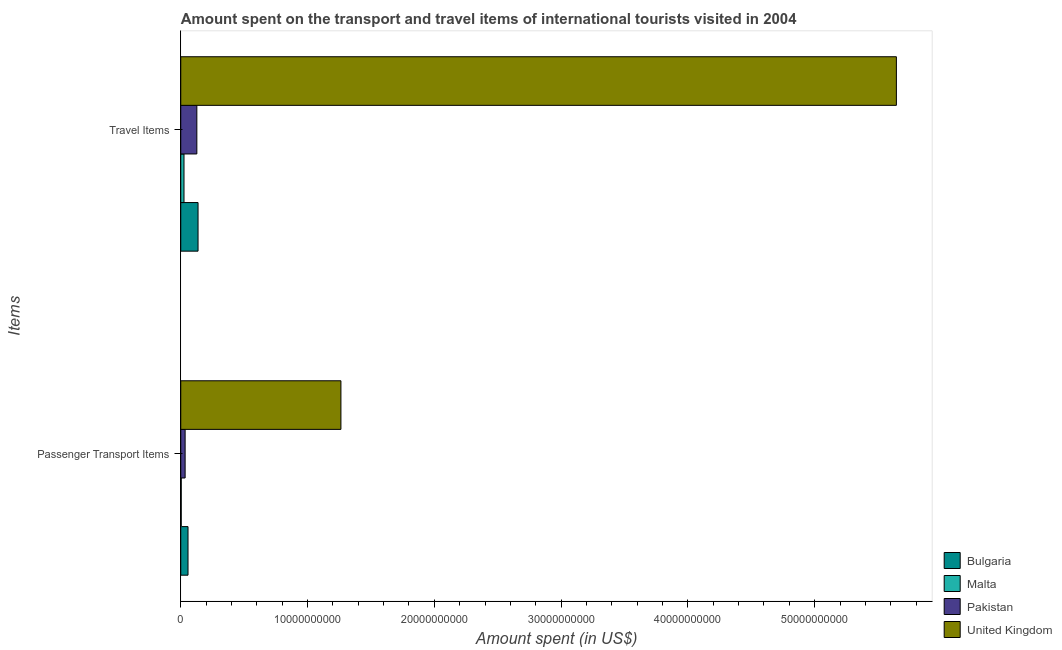Are the number of bars per tick equal to the number of legend labels?
Your answer should be very brief. Yes. Are the number of bars on each tick of the Y-axis equal?
Offer a very short reply. Yes. How many bars are there on the 1st tick from the top?
Ensure brevity in your answer.  4. How many bars are there on the 1st tick from the bottom?
Make the answer very short. 4. What is the label of the 2nd group of bars from the top?
Your answer should be very brief. Passenger Transport Items. What is the amount spent on passenger transport items in Bulgaria?
Keep it short and to the point. 5.72e+08. Across all countries, what is the maximum amount spent on passenger transport items?
Provide a short and direct response. 1.26e+1. Across all countries, what is the minimum amount spent on passenger transport items?
Offer a very short reply. 3.60e+07. In which country was the amount spent in travel items maximum?
Offer a very short reply. United Kingdom. In which country was the amount spent in travel items minimum?
Your answer should be compact. Malta. What is the total amount spent in travel items in the graph?
Offer a terse response. 5.93e+1. What is the difference between the amount spent on passenger transport items in United Kingdom and that in Pakistan?
Offer a terse response. 1.23e+1. What is the difference between the amount spent on passenger transport items in Malta and the amount spent in travel items in Bulgaria?
Provide a short and direct response. -1.33e+09. What is the average amount spent on passenger transport items per country?
Keep it short and to the point. 3.40e+09. What is the difference between the amount spent in travel items and amount spent on passenger transport items in Pakistan?
Offer a terse response. 9.24e+08. What is the ratio of the amount spent in travel items in Malta to that in Bulgaria?
Ensure brevity in your answer.  0.19. Is the amount spent in travel items in Bulgaria less than that in Malta?
Provide a succinct answer. No. In how many countries, is the amount spent in travel items greater than the average amount spent in travel items taken over all countries?
Offer a terse response. 1. What does the 3rd bar from the top in Travel Items represents?
Your response must be concise. Malta. Does the graph contain grids?
Your response must be concise. No. Where does the legend appear in the graph?
Keep it short and to the point. Bottom right. How many legend labels are there?
Keep it short and to the point. 4. How are the legend labels stacked?
Your answer should be very brief. Vertical. What is the title of the graph?
Your answer should be compact. Amount spent on the transport and travel items of international tourists visited in 2004. What is the label or title of the X-axis?
Offer a terse response. Amount spent (in US$). What is the label or title of the Y-axis?
Ensure brevity in your answer.  Items. What is the Amount spent (in US$) of Bulgaria in Passenger Transport Items?
Your answer should be very brief. 5.72e+08. What is the Amount spent (in US$) of Malta in Passenger Transport Items?
Offer a very short reply. 3.60e+07. What is the Amount spent (in US$) in Pakistan in Passenger Transport Items?
Keep it short and to the point. 3.44e+08. What is the Amount spent (in US$) in United Kingdom in Passenger Transport Items?
Provide a succinct answer. 1.26e+1. What is the Amount spent (in US$) of Bulgaria in Travel Items?
Provide a succinct answer. 1.36e+09. What is the Amount spent (in US$) in Malta in Travel Items?
Provide a succinct answer. 2.55e+08. What is the Amount spent (in US$) of Pakistan in Travel Items?
Make the answer very short. 1.27e+09. What is the Amount spent (in US$) in United Kingdom in Travel Items?
Provide a short and direct response. 5.64e+1. Across all Items, what is the maximum Amount spent (in US$) in Bulgaria?
Your response must be concise. 1.36e+09. Across all Items, what is the maximum Amount spent (in US$) in Malta?
Offer a very short reply. 2.55e+08. Across all Items, what is the maximum Amount spent (in US$) of Pakistan?
Your answer should be very brief. 1.27e+09. Across all Items, what is the maximum Amount spent (in US$) of United Kingdom?
Your response must be concise. 5.64e+1. Across all Items, what is the minimum Amount spent (in US$) of Bulgaria?
Your response must be concise. 5.72e+08. Across all Items, what is the minimum Amount spent (in US$) in Malta?
Offer a very short reply. 3.60e+07. Across all Items, what is the minimum Amount spent (in US$) in Pakistan?
Give a very brief answer. 3.44e+08. Across all Items, what is the minimum Amount spent (in US$) of United Kingdom?
Offer a terse response. 1.26e+1. What is the total Amount spent (in US$) of Bulgaria in the graph?
Your answer should be very brief. 1.94e+09. What is the total Amount spent (in US$) in Malta in the graph?
Give a very brief answer. 2.91e+08. What is the total Amount spent (in US$) of Pakistan in the graph?
Keep it short and to the point. 1.61e+09. What is the total Amount spent (in US$) in United Kingdom in the graph?
Keep it short and to the point. 6.91e+1. What is the difference between the Amount spent (in US$) of Bulgaria in Passenger Transport Items and that in Travel Items?
Make the answer very short. -7.91e+08. What is the difference between the Amount spent (in US$) in Malta in Passenger Transport Items and that in Travel Items?
Offer a very short reply. -2.19e+08. What is the difference between the Amount spent (in US$) of Pakistan in Passenger Transport Items and that in Travel Items?
Your answer should be very brief. -9.24e+08. What is the difference between the Amount spent (in US$) in United Kingdom in Passenger Transport Items and that in Travel Items?
Provide a succinct answer. -4.38e+1. What is the difference between the Amount spent (in US$) of Bulgaria in Passenger Transport Items and the Amount spent (in US$) of Malta in Travel Items?
Offer a very short reply. 3.17e+08. What is the difference between the Amount spent (in US$) of Bulgaria in Passenger Transport Items and the Amount spent (in US$) of Pakistan in Travel Items?
Provide a succinct answer. -6.96e+08. What is the difference between the Amount spent (in US$) in Bulgaria in Passenger Transport Items and the Amount spent (in US$) in United Kingdom in Travel Items?
Your response must be concise. -5.59e+1. What is the difference between the Amount spent (in US$) of Malta in Passenger Transport Items and the Amount spent (in US$) of Pakistan in Travel Items?
Give a very brief answer. -1.23e+09. What is the difference between the Amount spent (in US$) in Malta in Passenger Transport Items and the Amount spent (in US$) in United Kingdom in Travel Items?
Give a very brief answer. -5.64e+1. What is the difference between the Amount spent (in US$) in Pakistan in Passenger Transport Items and the Amount spent (in US$) in United Kingdom in Travel Items?
Ensure brevity in your answer.  -5.61e+1. What is the average Amount spent (in US$) of Bulgaria per Items?
Provide a succinct answer. 9.68e+08. What is the average Amount spent (in US$) of Malta per Items?
Your response must be concise. 1.46e+08. What is the average Amount spent (in US$) of Pakistan per Items?
Keep it short and to the point. 8.06e+08. What is the average Amount spent (in US$) of United Kingdom per Items?
Your answer should be compact. 3.45e+1. What is the difference between the Amount spent (in US$) in Bulgaria and Amount spent (in US$) in Malta in Passenger Transport Items?
Your answer should be compact. 5.36e+08. What is the difference between the Amount spent (in US$) of Bulgaria and Amount spent (in US$) of Pakistan in Passenger Transport Items?
Provide a succinct answer. 2.28e+08. What is the difference between the Amount spent (in US$) in Bulgaria and Amount spent (in US$) in United Kingdom in Passenger Transport Items?
Offer a very short reply. -1.21e+1. What is the difference between the Amount spent (in US$) of Malta and Amount spent (in US$) of Pakistan in Passenger Transport Items?
Ensure brevity in your answer.  -3.08e+08. What is the difference between the Amount spent (in US$) in Malta and Amount spent (in US$) in United Kingdom in Passenger Transport Items?
Your response must be concise. -1.26e+1. What is the difference between the Amount spent (in US$) of Pakistan and Amount spent (in US$) of United Kingdom in Passenger Transport Items?
Make the answer very short. -1.23e+1. What is the difference between the Amount spent (in US$) of Bulgaria and Amount spent (in US$) of Malta in Travel Items?
Provide a short and direct response. 1.11e+09. What is the difference between the Amount spent (in US$) of Bulgaria and Amount spent (in US$) of Pakistan in Travel Items?
Give a very brief answer. 9.50e+07. What is the difference between the Amount spent (in US$) of Bulgaria and Amount spent (in US$) of United Kingdom in Travel Items?
Keep it short and to the point. -5.51e+1. What is the difference between the Amount spent (in US$) in Malta and Amount spent (in US$) in Pakistan in Travel Items?
Your response must be concise. -1.01e+09. What is the difference between the Amount spent (in US$) of Malta and Amount spent (in US$) of United Kingdom in Travel Items?
Offer a very short reply. -5.62e+1. What is the difference between the Amount spent (in US$) in Pakistan and Amount spent (in US$) in United Kingdom in Travel Items?
Offer a terse response. -5.52e+1. What is the ratio of the Amount spent (in US$) of Bulgaria in Passenger Transport Items to that in Travel Items?
Make the answer very short. 0.42. What is the ratio of the Amount spent (in US$) in Malta in Passenger Transport Items to that in Travel Items?
Provide a short and direct response. 0.14. What is the ratio of the Amount spent (in US$) in Pakistan in Passenger Transport Items to that in Travel Items?
Give a very brief answer. 0.27. What is the ratio of the Amount spent (in US$) in United Kingdom in Passenger Transport Items to that in Travel Items?
Your response must be concise. 0.22. What is the difference between the highest and the second highest Amount spent (in US$) in Bulgaria?
Offer a very short reply. 7.91e+08. What is the difference between the highest and the second highest Amount spent (in US$) of Malta?
Make the answer very short. 2.19e+08. What is the difference between the highest and the second highest Amount spent (in US$) in Pakistan?
Your response must be concise. 9.24e+08. What is the difference between the highest and the second highest Amount spent (in US$) in United Kingdom?
Ensure brevity in your answer.  4.38e+1. What is the difference between the highest and the lowest Amount spent (in US$) of Bulgaria?
Provide a short and direct response. 7.91e+08. What is the difference between the highest and the lowest Amount spent (in US$) in Malta?
Provide a succinct answer. 2.19e+08. What is the difference between the highest and the lowest Amount spent (in US$) in Pakistan?
Your answer should be compact. 9.24e+08. What is the difference between the highest and the lowest Amount spent (in US$) in United Kingdom?
Your response must be concise. 4.38e+1. 